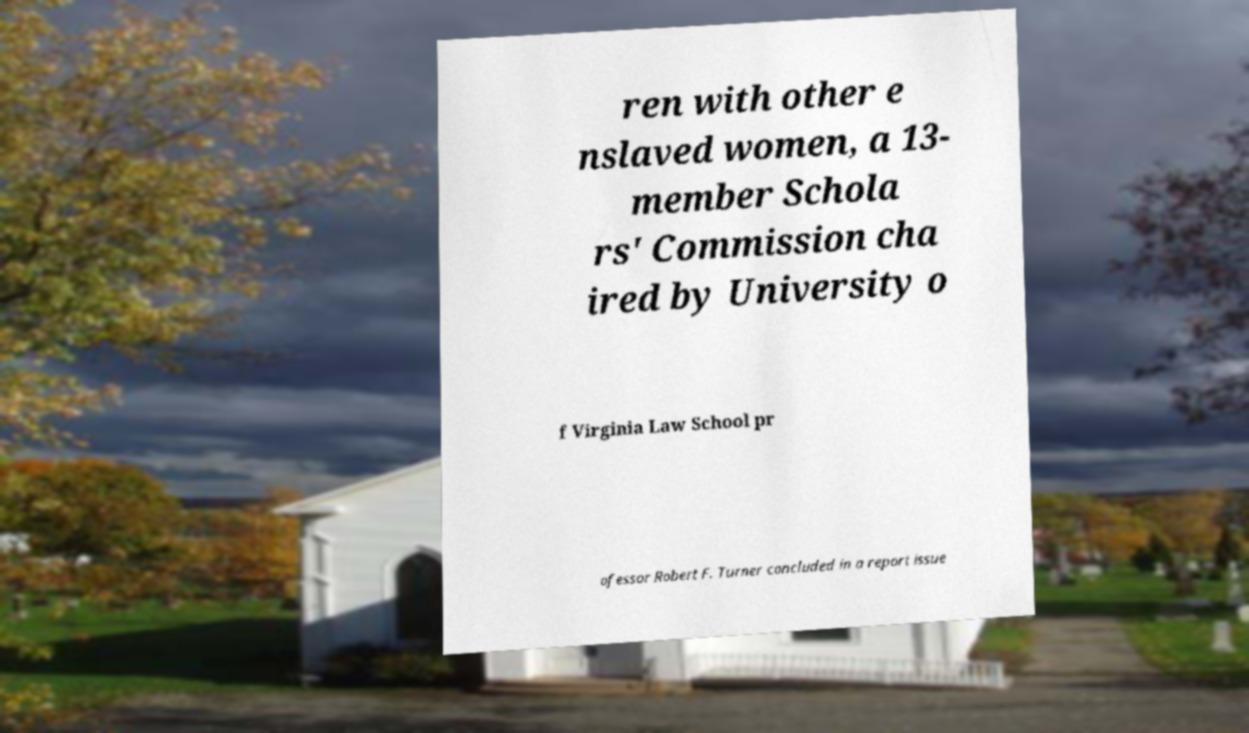There's text embedded in this image that I need extracted. Can you transcribe it verbatim? ren with other e nslaved women, a 13- member Schola rs' Commission cha ired by University o f Virginia Law School pr ofessor Robert F. Turner concluded in a report issue 